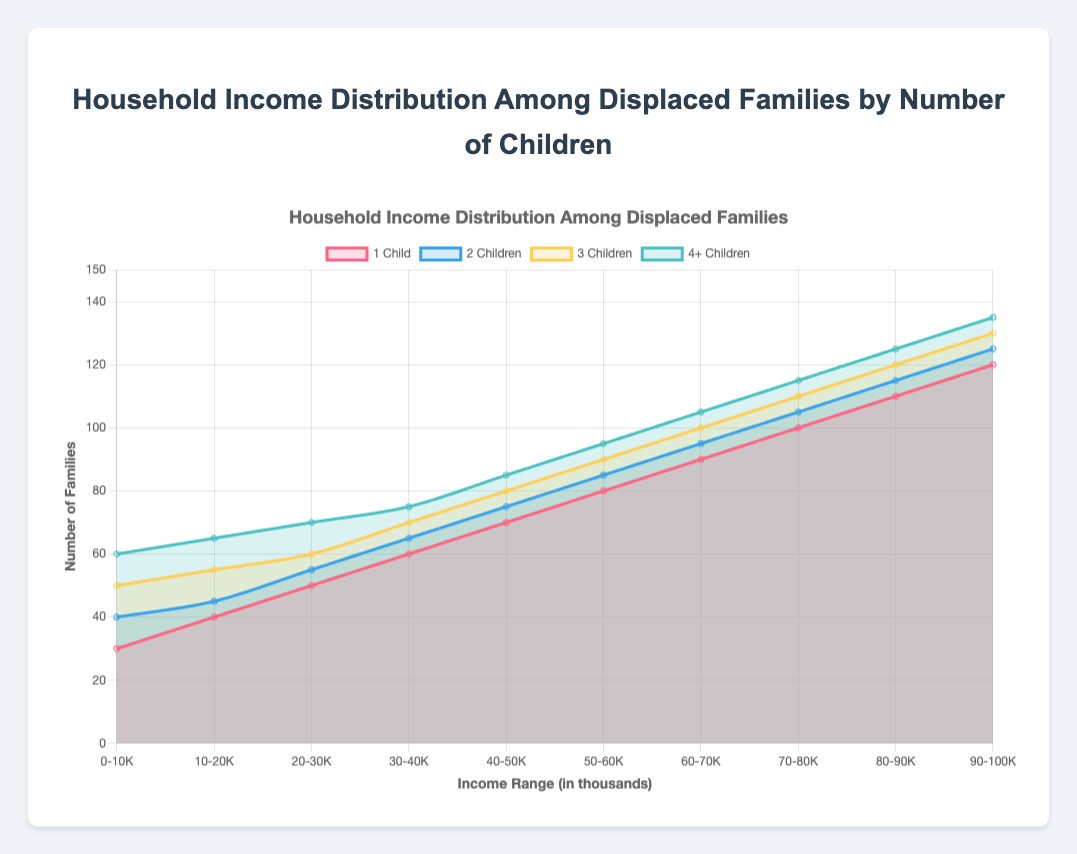What's the title of the chart? The title of the chart can be easily identified as it is usually displayed at the top. In this case, the title is visible at the top of the chart and reads "Household Income Distribution Among Displaced Families by Number of Children."
Answer: Household Income Distribution Among Displaced Families by Number of Children What is the income range with the highest number of families with 4+ children? To find the income range with the highest number of families with 4+ children, we look for the maximum value in the "4+ Children" dataset within the chart and then locate the corresponding income range. From the data, the highest value is 135, which lies in the "90-100K" range.
Answer: 90-100K How many families with 1 child have an income between 20K and 30K? To answer this, we locate the "20-30K" income range and check the value associated with "1 Child" on the chart, which is 50.
Answer: 50 Compare the number of families with 2 children in the 40-50K and 80-90K income ranges. Which range has more families? We need to find the values in the "40-50K" and "80-90K" income ranges for "2 Children." From the chart, the values are 75 for the 40-50K range and 115 for the 80-90K range. Comparing these, 115 is greater than 75.
Answer: 80-90K What was the overall increase in the number of families with 3 children when moving from the "0-10K" to "90-100K" income range? Subtract the number of families in the "0-10K" range from the number of families in the "90-100K" range for "3 Children." The values are 130 (90-100K) - 50 (0-10K), resulting in an increase of 80 families.
Answer: 80 Which group has the sharpest rise in the number of families as the income range increases? To determine the group with the sharpest rise, we analyze the slope or change in values across income ranges for each group. The "4+ Children" group has the highest increase from 60 to 135, indicating the sharpest rise.
Answer: 4+ Children In the income range of 60-70K, how much more families with 3 children are there compared to families with 1 child? From the chart, the number of families with 3 children in the "60-70K" range is 100, and for 1 child, it is 90. The difference is 100 - 90 = 10 families.
Answer: 10 Which income range has an equal number of families with 2 children and 4+ children? Searching for the income range where the values for "2 Children" and "4+ Children" are the same. In this chart, there is no income range where these numbers are equal (e.g., 45 ≠ 65, 55 ≠ 70, etc.).
Answer: None If you sum up the number of families with 1 child across all income ranges, what is the total? Adding the values for "1 Child" across all income ranges: 30 + 40 + 50 + 60 + 70 + 80 + 90 + 100 + 110 + 120. This equals 750.
Answer: 750 What is the average number of families with 2 children in the income ranges from 0K to 50K? For the "2 Children" group, sum the values in the income ranges 0-10K, 10-20K, 20-30K, 30-40K, and 40-50K, then divide by the number of ranges (5): (40 + 45 + 55 + 65 + 75) / 5 = 56.
Answer: 56 